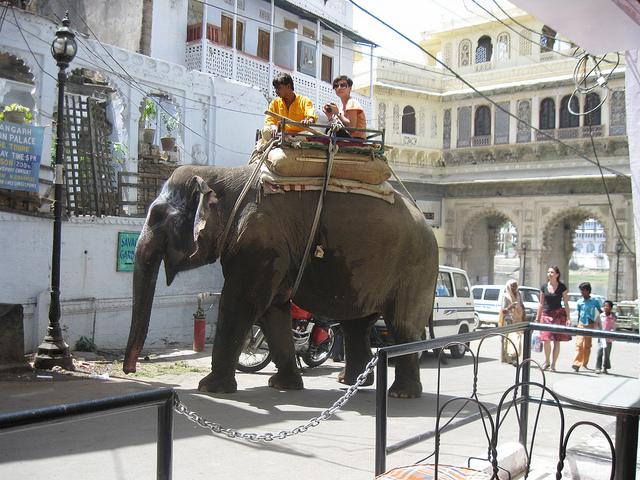What animal is in front of the camera?
Be succinct. Elephant. Does the elephant depicted have his trunk in the air?
Quick response, please. No. What is between the seat and the elephant?
Give a very brief answer. Blankets. What is the man riding?
Be succinct. Elephant. How many animals are in the picture?
Quick response, please. 1. Where are they at?
Answer briefly. India. How many elephants?
Short answer required. 1. What are they doing?
Quick response, please. Riding elephant. How many people are riding the elephant?
Quick response, please. 2. 